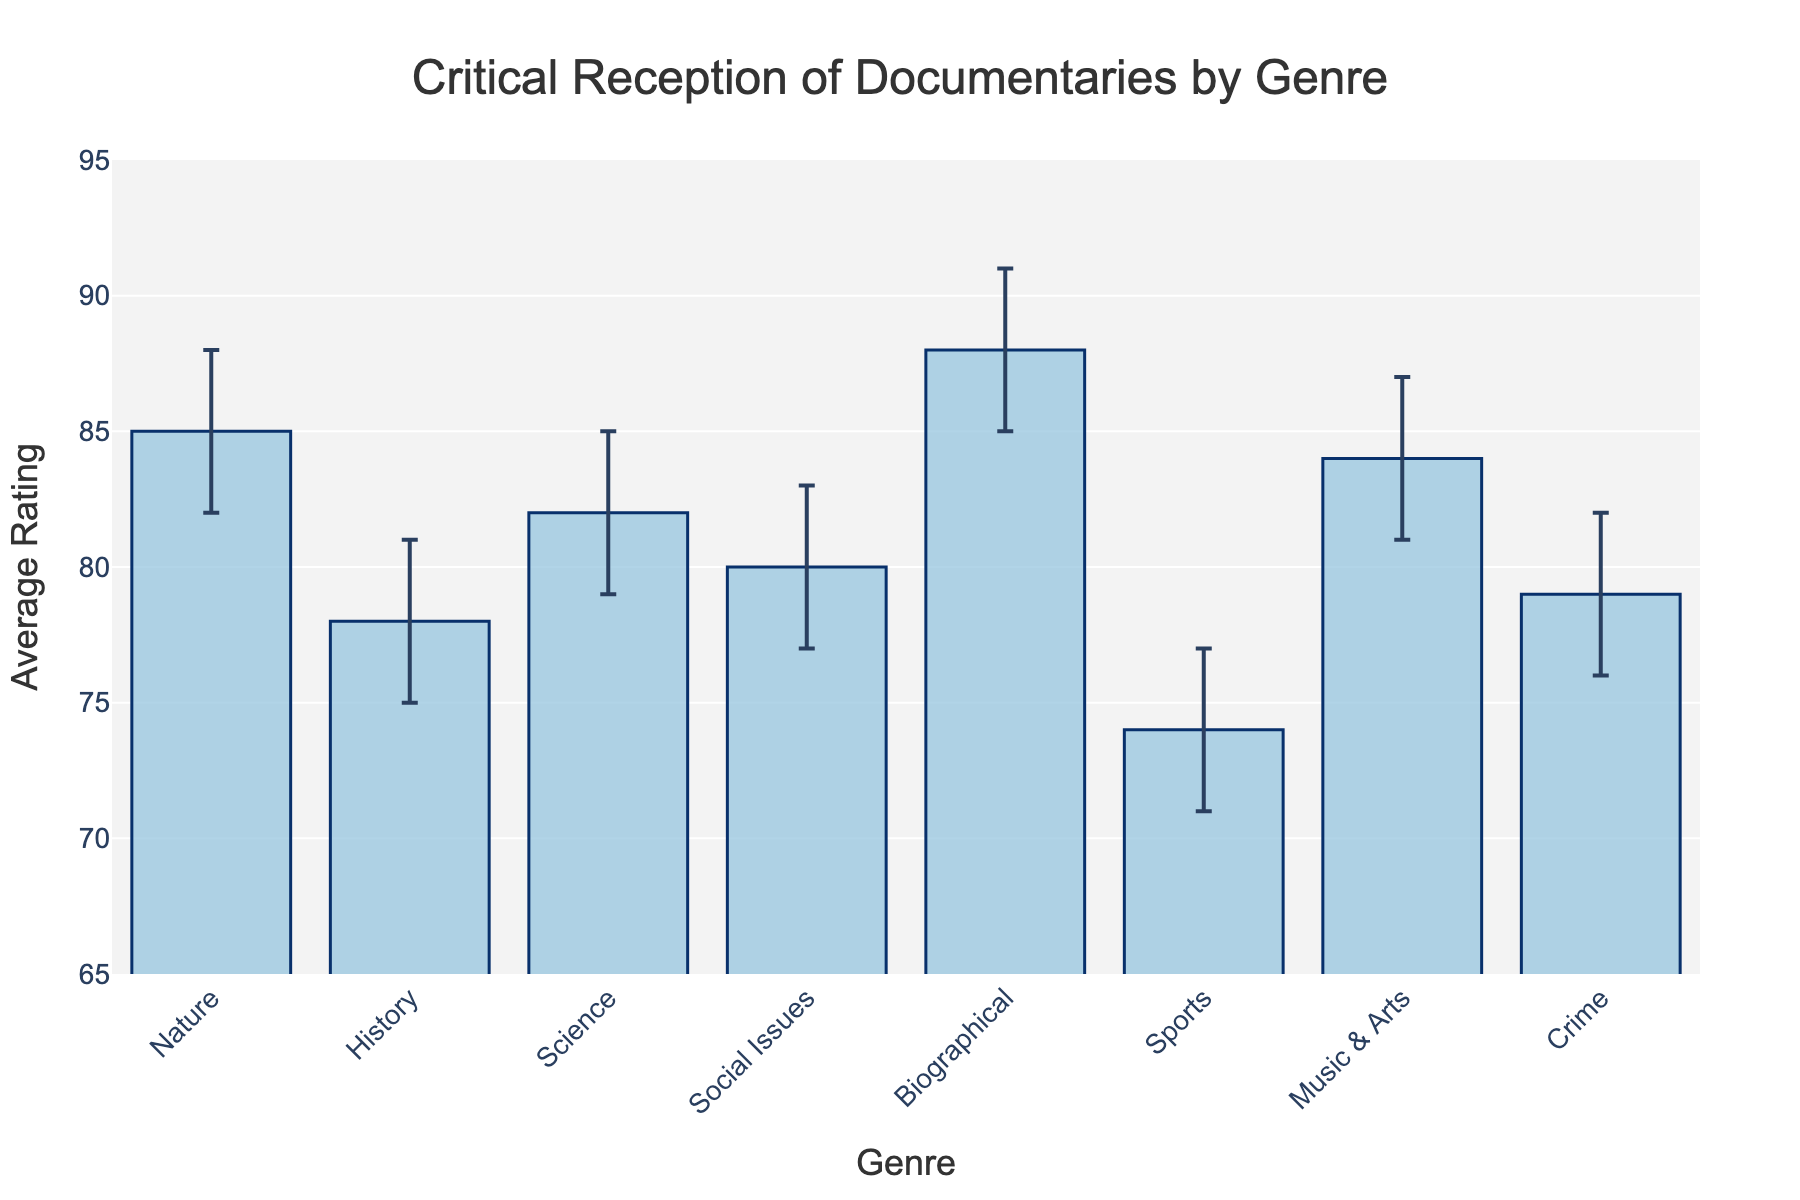What is the average rating for Biographical documentaries? The figure shows the average ratings for each genre, with Biographical documentaries having an average rating of 88.
Answer: 88 Which genre has the lowest average critical rating? By examining the bars, Sports documentaries have the lowest average rating of 74 among all genres.
Answer: Sports What is the average critical rating for Science documentaries, and how does it compare to Social Issues documentaries? The average rating for Science documentaries is 82 and for Social Issues documentaries is 80. The rating for Science documentaries is higher.
Answer: 82; higher Between Music & Arts and Crime documentaries, which has more variability in its confidence interval? Music & Arts documentaries have a confidence interval range of 81 to 87 (6 units), and Crime documentaries range from 76 to 82 (6 units). Both have the same variability.
Answer: Same How wide is the confidence interval for History documentaries? The confidence interval for History documentaries is from 75 to 81. The width is 81 - 75 = 6.
Answer: 6 What does the error bar represent in this chart? The error bar represents the confidence interval around the average rating, showing the range within which the true rating likely falls.
Answer: Confidence interval Rank the genres from highest to lowest average rating. Based on the figure: Biographical (88), Nature (85), Music & Arts (84), Science (82), Social Issues (80), Crime (79), History (78), Sports (74).
Answer: Biographical, Nature, Music & Arts, Science, Social Issues, Crime, History, Sports What is the range of average ratings across all genres? The highest average rating is 88 (Biographical), and the lowest is 74 (Sports). The range is 88 - 74 = 14.
Answer: 14 Does any genre have an average rating below 75? Sports documentaries have an average rating of 74, which is below 75.
Answer: Yes Which genre has the highest upper confidence interval? Biographical documentaries have the highest upper confidence interval of 91.
Answer: Biographical 